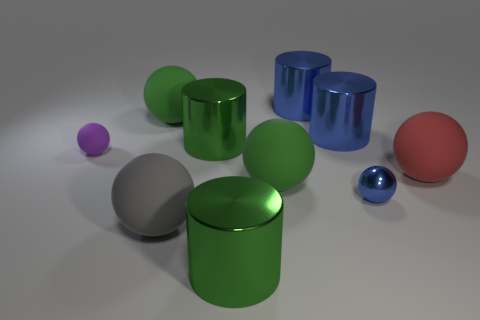Subtract 2 balls. How many balls are left? 4 Subtract all red spheres. How many spheres are left? 5 Subtract all tiny spheres. How many spheres are left? 4 Subtract all cyan spheres. Subtract all yellow cylinders. How many spheres are left? 6 Subtract all spheres. How many objects are left? 4 Subtract 0 purple cylinders. How many objects are left? 10 Subtract all metal cylinders. Subtract all big green rubber balls. How many objects are left? 4 Add 5 purple rubber spheres. How many purple rubber spheres are left? 6 Add 2 green metal cylinders. How many green metal cylinders exist? 4 